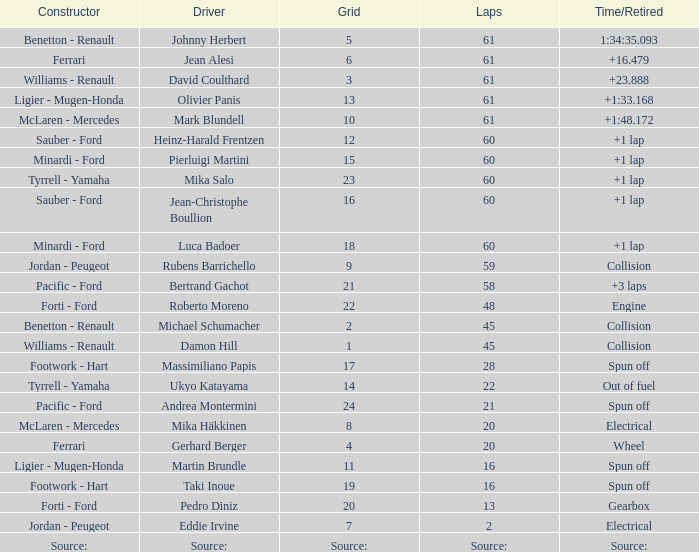What grid has 2 laps? 7.0. 